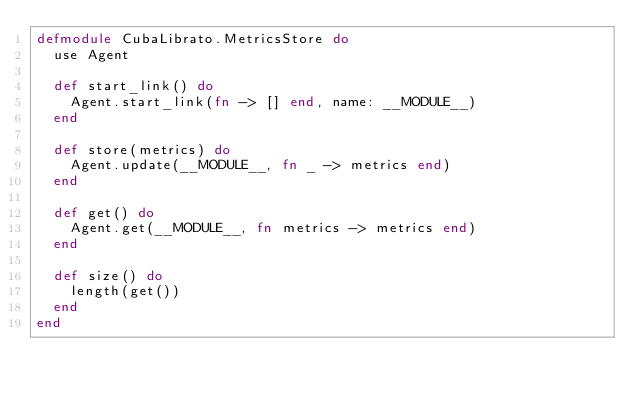Convert code to text. <code><loc_0><loc_0><loc_500><loc_500><_Elixir_>defmodule CubaLibrato.MetricsStore do
  use Agent

  def start_link() do
    Agent.start_link(fn -> [] end, name: __MODULE__)
  end

  def store(metrics) do
    Agent.update(__MODULE__, fn _ -> metrics end)
  end

  def get() do
    Agent.get(__MODULE__, fn metrics -> metrics end)
  end

  def size() do
    length(get())
  end
end
</code> 